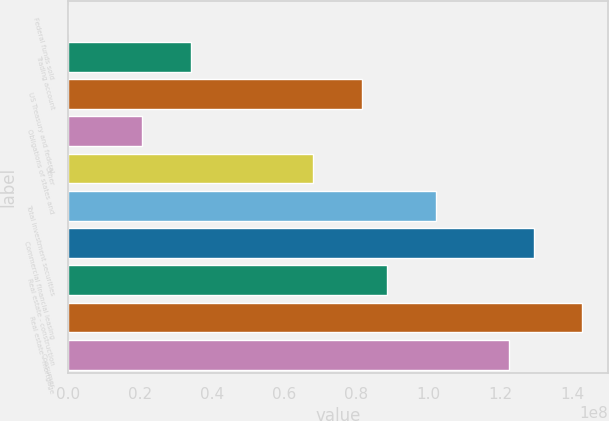<chart> <loc_0><loc_0><loc_500><loc_500><bar_chart><fcel>Federal funds sold<fcel>Trading account<fcel>US Treasury and federal<fcel>Obligations of states and<fcel>Other<fcel>Total investment securities<fcel>Commercial financial leasing<fcel>Real estate - construction<fcel>Real estate - mortgage<fcel>Consumer<nl><fcel>25000<fcel>3.40231e+07<fcel>8.16205e+07<fcel>2.04239e+07<fcel>6.80213e+07<fcel>1.02019e+08<fcel>1.29218e+08<fcel>8.84201e+07<fcel>1.42817e+08<fcel>1.22418e+08<nl></chart> 